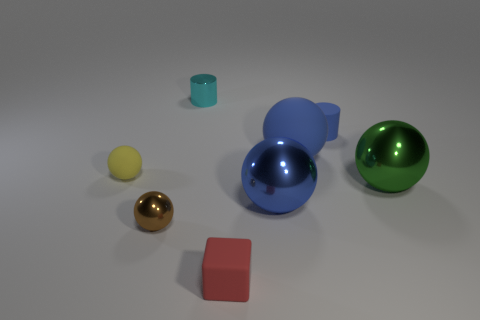Subtract all yellow spheres. How many spheres are left? 4 Subtract all blue shiny balls. How many balls are left? 4 Subtract all purple spheres. Subtract all cyan blocks. How many spheres are left? 5 Add 1 large gray metal blocks. How many objects exist? 9 Subtract all cylinders. How many objects are left? 6 Subtract all yellow rubber objects. Subtract all large metallic things. How many objects are left? 5 Add 4 yellow rubber spheres. How many yellow rubber spheres are left? 5 Add 4 small cyan blocks. How many small cyan blocks exist? 4 Subtract 1 blue spheres. How many objects are left? 7 